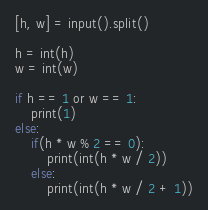<code> <loc_0><loc_0><loc_500><loc_500><_Python_>[h, w] = input().split()

h = int(h)
w = int(w)

if h == 1 or w == 1:
    print(1)
else:
    if(h * w % 2 == 0):
        print(int(h * w / 2))
    else:
        print(int(h * w / 2 + 1))
</code> 